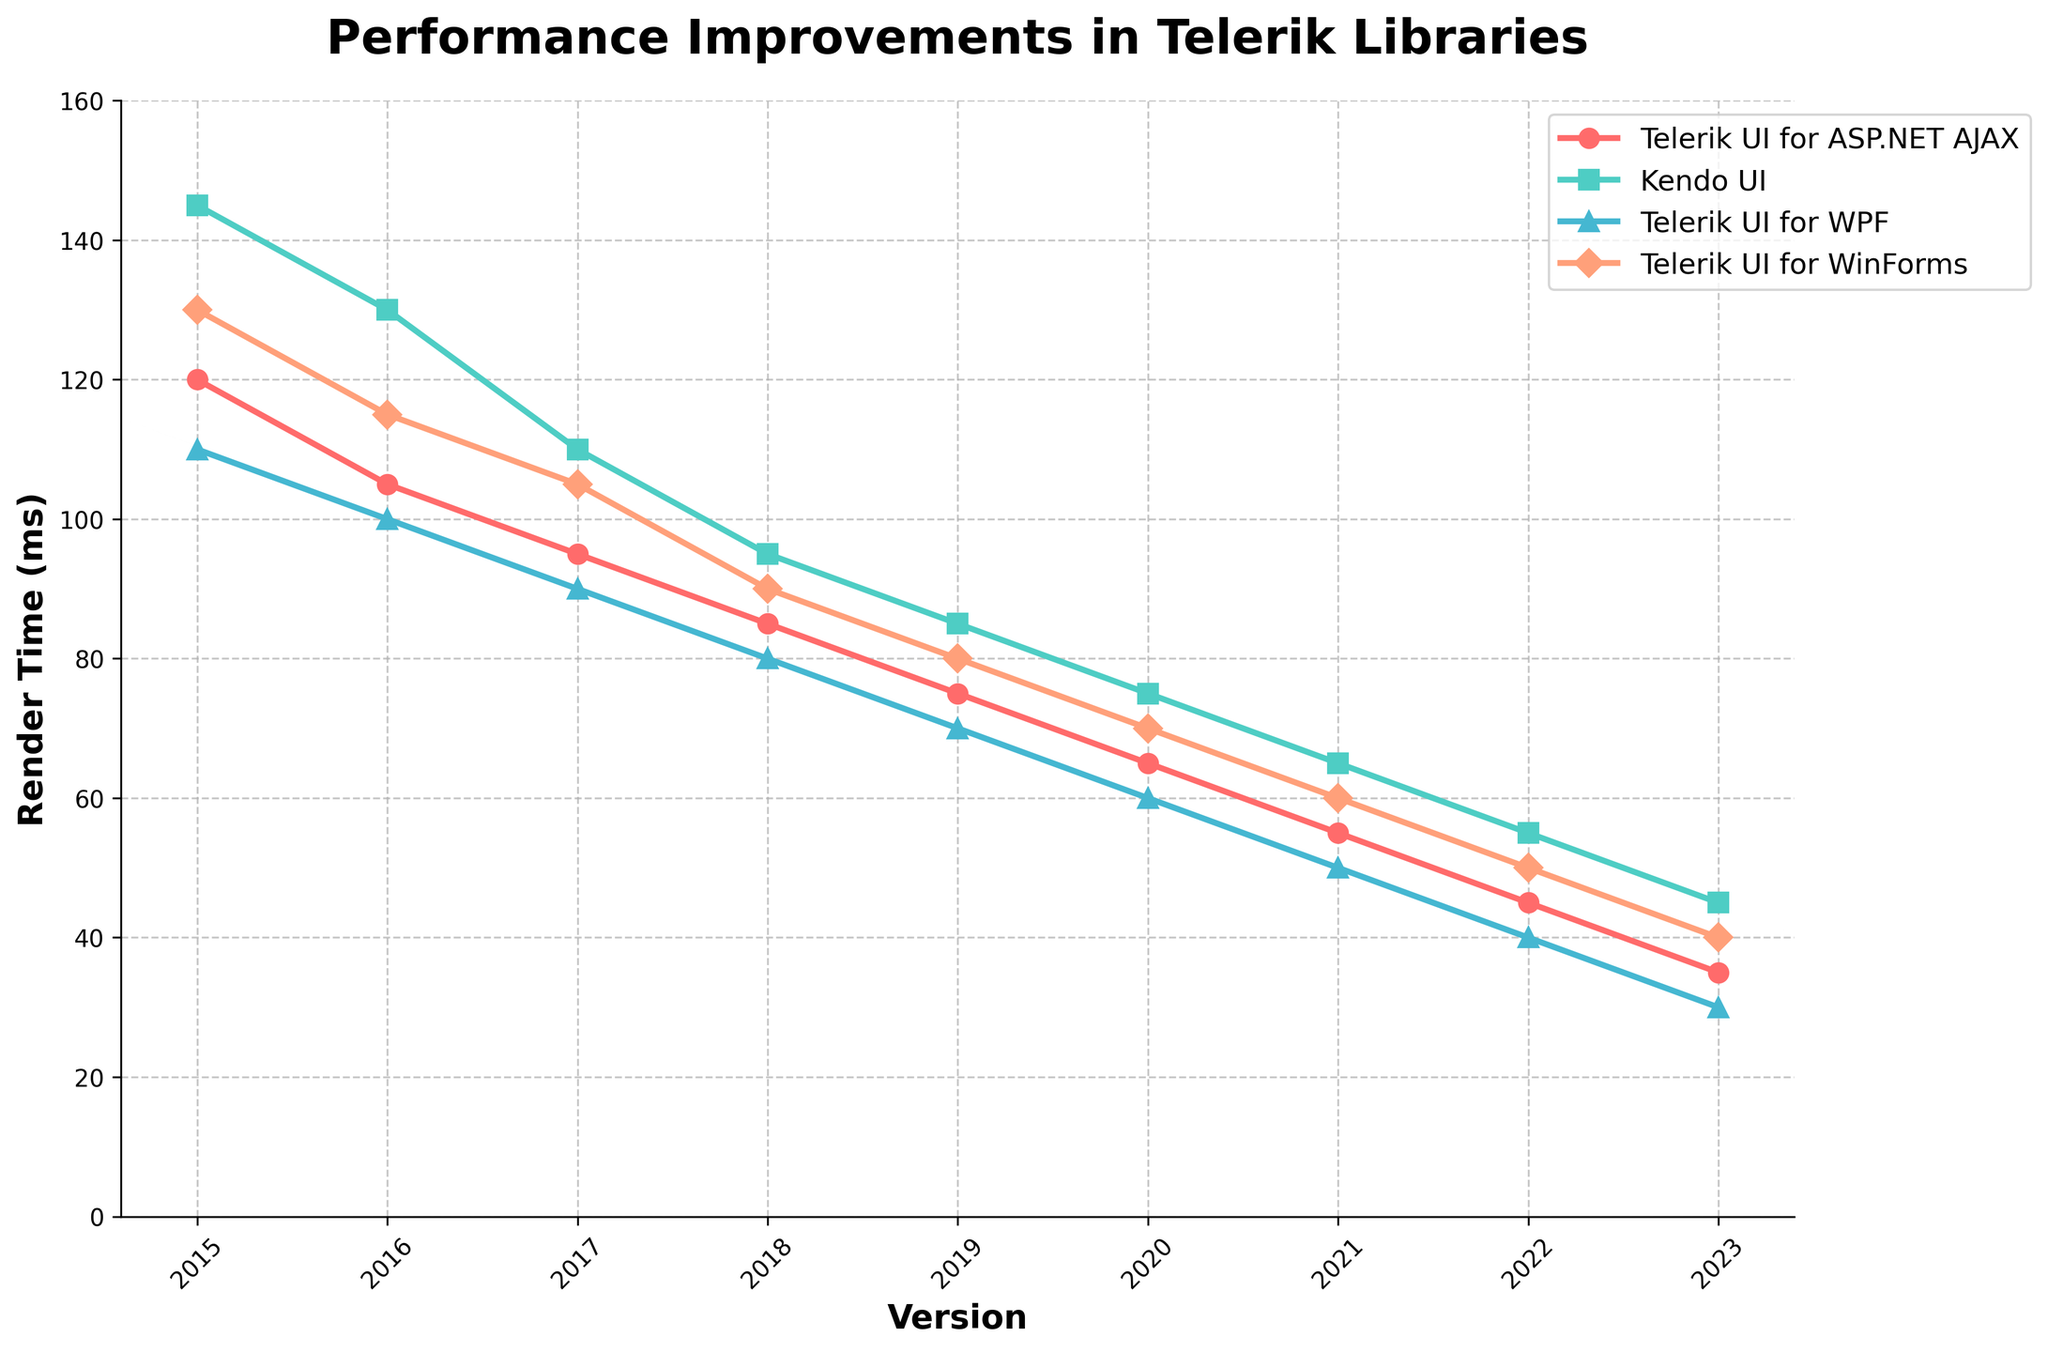How has the render time for Telerik UI for ASP.NET AJAX changed from 2015 to 2023? In the figure, the render time for Telerik UI for ASP.NET AJAX starts at 120 ms in 2015 and decreases to 35 ms in 2023. The change is calculated as 120 - 35.
Answer: The render time decreased by 85 ms Which Telerik library had the lowest render time in 2023? By observing the plot for 2023, we identify that Telerik UI for WinForms has the lowest render time at around 30 ms compared to other libraries.
Answer: Telerik UI for WinForms Between 2017 and 2020, which Telerik library had the most significant reduction in render time? To answer, subtract the 2020 render times from the 2017 render times for each library and compare the differences. 
- ASP.NET AJAX: 95 - 65 = 30 ms
- Kendo UI: 110 - 75 = 35 ms
- WPF: 90 - 60 = 30 ms
- WinForms: 105 - 70 = 35 ms 
Kendo UI and Telerik UI for WinForms have the most significant reductions of 35 ms each.
Answer: Kendo UI, Telerik UI for WinForms What is the average render time for Kendo UI from 2015 to 2023? Add the render times for Kendo UI from each year and divide by the number of years.
(145 + 130 + 110 + 95 + 85 + 75 + 65 + 55 + 45) / 9 = 805 / 9 = ~89.44 ms
Answer: ~89.44 ms Which year shows the most significant improvement in render time for Telerik UI for WPF? To find out, calculate the year-to-year differences for WPF render times and determine the maximum decrease:
- 2015-2016: 110 - 100 = 10 ms
- 2016-2017: 100 - 90 = 10 ms
- 2017-2018: 90 - 80 = 10 ms
- 2018-2019: 80 - 70 = 10 ms
- 2019-2020: 70 - 60 = 10 ms
- 2020-2021: 60 - 50 = 10 ms
- 2021-2022: 50 - 40 = 10 ms
- 2022-2023: 40 - 30 = 10 ms 
The most significant improvements are equal at 10 ms per year.
Answer: Each year from 2015 to 2023 shows an equal improvement of 10 ms Comparing 2019 render times, which Telerik library had the greatest difference compared to Telerik UI for WinForms in the same year? Compare each library's render times with that of WinForms in 2019:
- ASP.NET AJAX: 75 - 80 = -5 ms
- Kendo UI: 85 - 80 = 5 ms
- WPF: 70 - 80 = -10 ms 
The maximum difference is 10 ms with Telerik UI for WPF being lower by 10 ms.
Answer: Telerik UI for WPF 